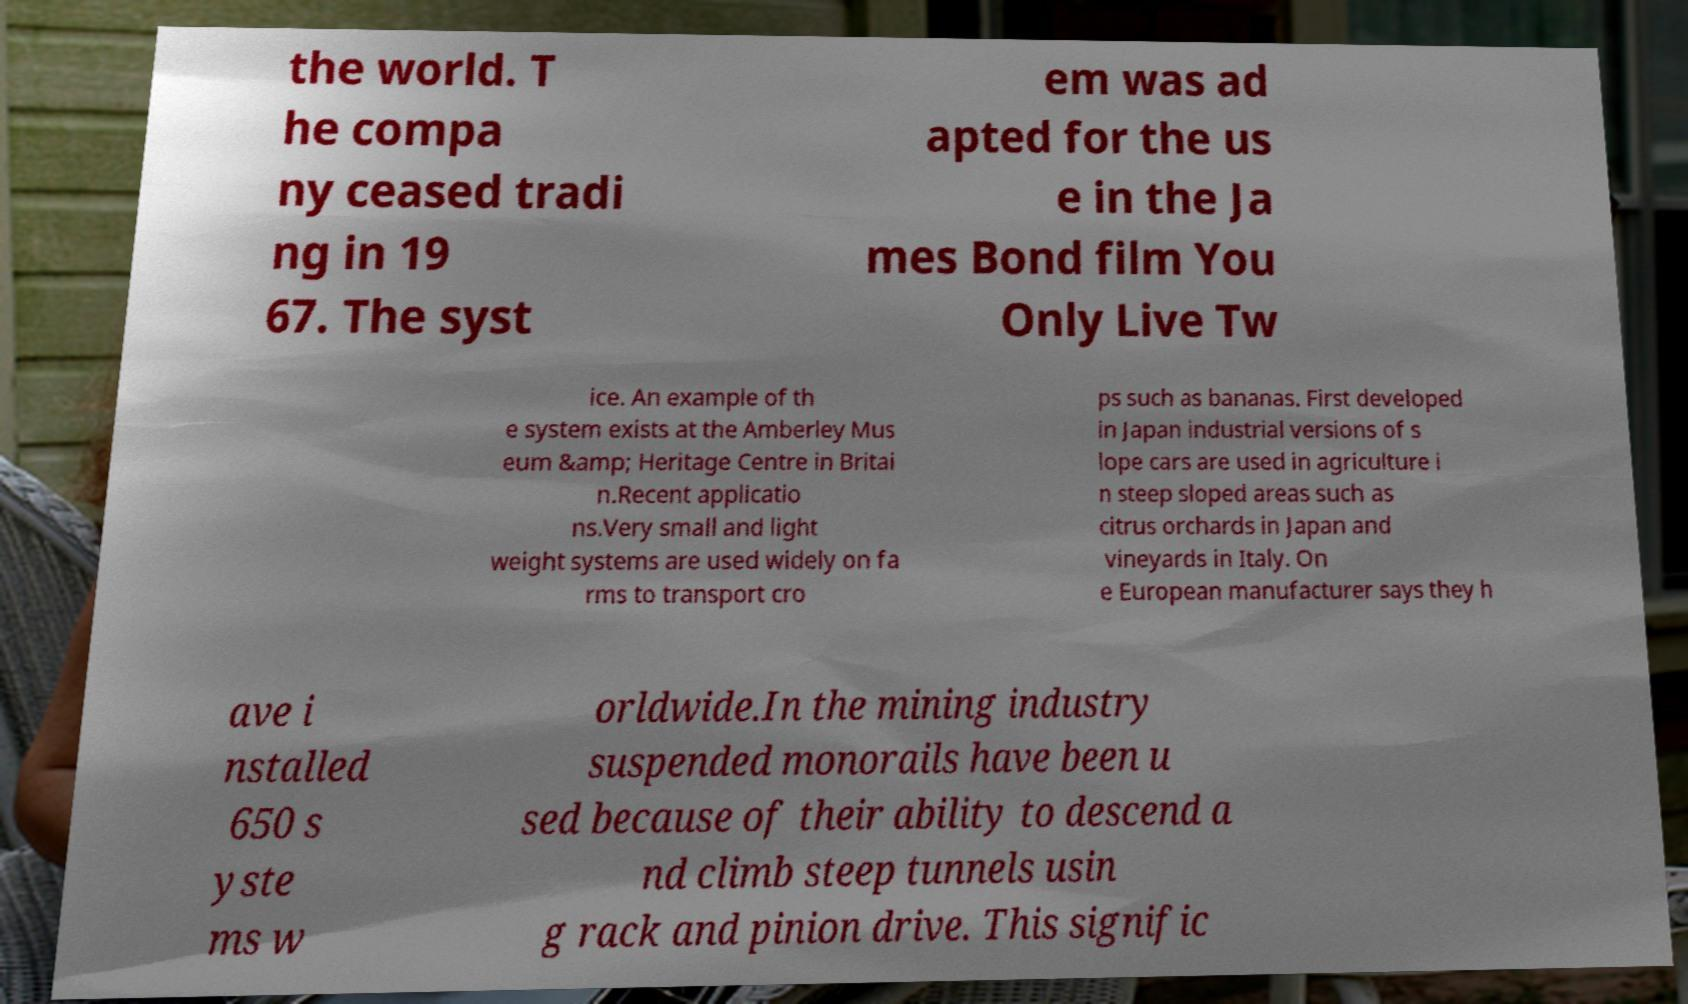Can you read and provide the text displayed in the image?This photo seems to have some interesting text. Can you extract and type it out for me? the world. T he compa ny ceased tradi ng in 19 67. The syst em was ad apted for the us e in the Ja mes Bond film You Only Live Tw ice. An example of th e system exists at the Amberley Mus eum &amp; Heritage Centre in Britai n.Recent applicatio ns.Very small and light weight systems are used widely on fa rms to transport cro ps such as bananas. First developed in Japan industrial versions of s lope cars are used in agriculture i n steep sloped areas such as citrus orchards in Japan and vineyards in Italy. On e European manufacturer says they h ave i nstalled 650 s yste ms w orldwide.In the mining industry suspended monorails have been u sed because of their ability to descend a nd climb steep tunnels usin g rack and pinion drive. This signific 